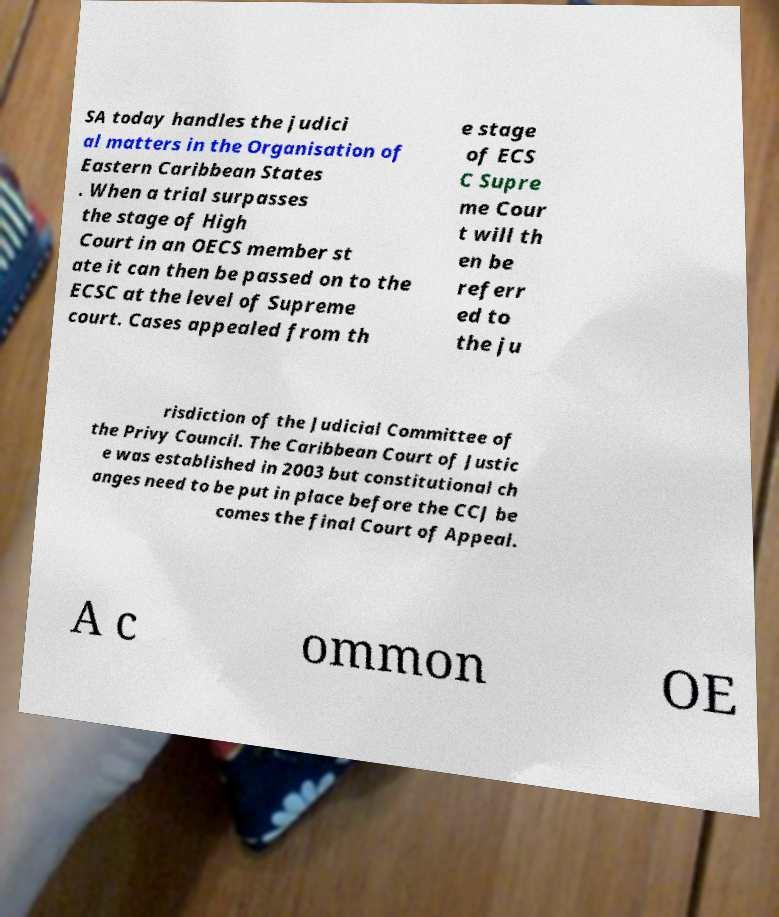Can you read and provide the text displayed in the image?This photo seems to have some interesting text. Can you extract and type it out for me? SA today handles the judici al matters in the Organisation of Eastern Caribbean States . When a trial surpasses the stage of High Court in an OECS member st ate it can then be passed on to the ECSC at the level of Supreme court. Cases appealed from th e stage of ECS C Supre me Cour t will th en be referr ed to the ju risdiction of the Judicial Committee of the Privy Council. The Caribbean Court of Justic e was established in 2003 but constitutional ch anges need to be put in place before the CCJ be comes the final Court of Appeal. A c ommon OE 